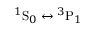<formula> <loc_0><loc_0><loc_500><loc_500>{ ^ { 1 } } S _ { 0 } { ^ { 3 } } P _ { 1 }</formula> 